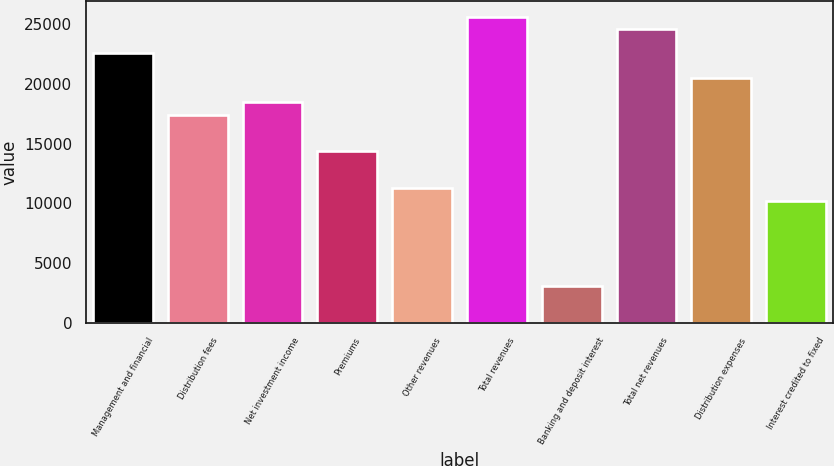Convert chart to OTSL. <chart><loc_0><loc_0><loc_500><loc_500><bar_chart><fcel>Management and financial<fcel>Distribution fees<fcel>Net investment income<fcel>Premiums<fcel>Other revenues<fcel>Total revenues<fcel>Banking and deposit interest<fcel>Total net revenues<fcel>Distribution expenses<fcel>Interest credited to fixed<nl><fcel>22524.5<fcel>17405.5<fcel>18429.3<fcel>14334.2<fcel>11262.8<fcel>25595.8<fcel>3072.52<fcel>24572<fcel>20476.9<fcel>10239<nl></chart> 